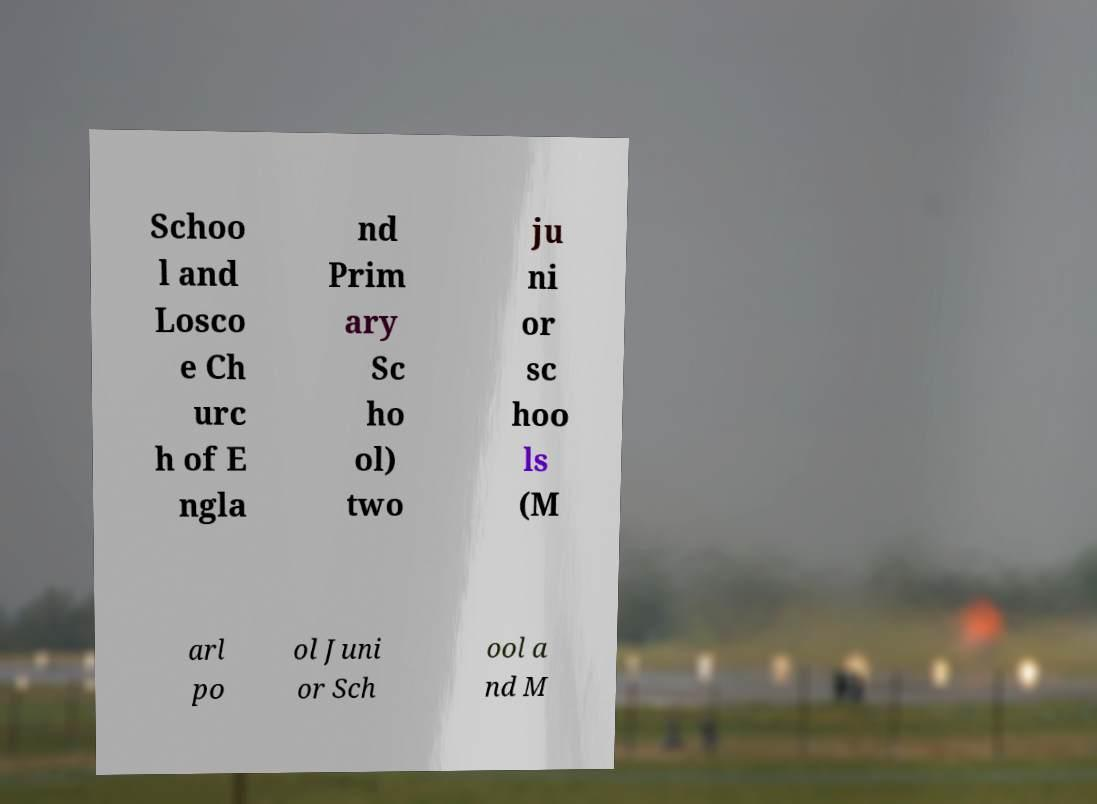Could you extract and type out the text from this image? Schoo l and Losco e Ch urc h of E ngla nd Prim ary Sc ho ol) two ju ni or sc hoo ls (M arl po ol Juni or Sch ool a nd M 